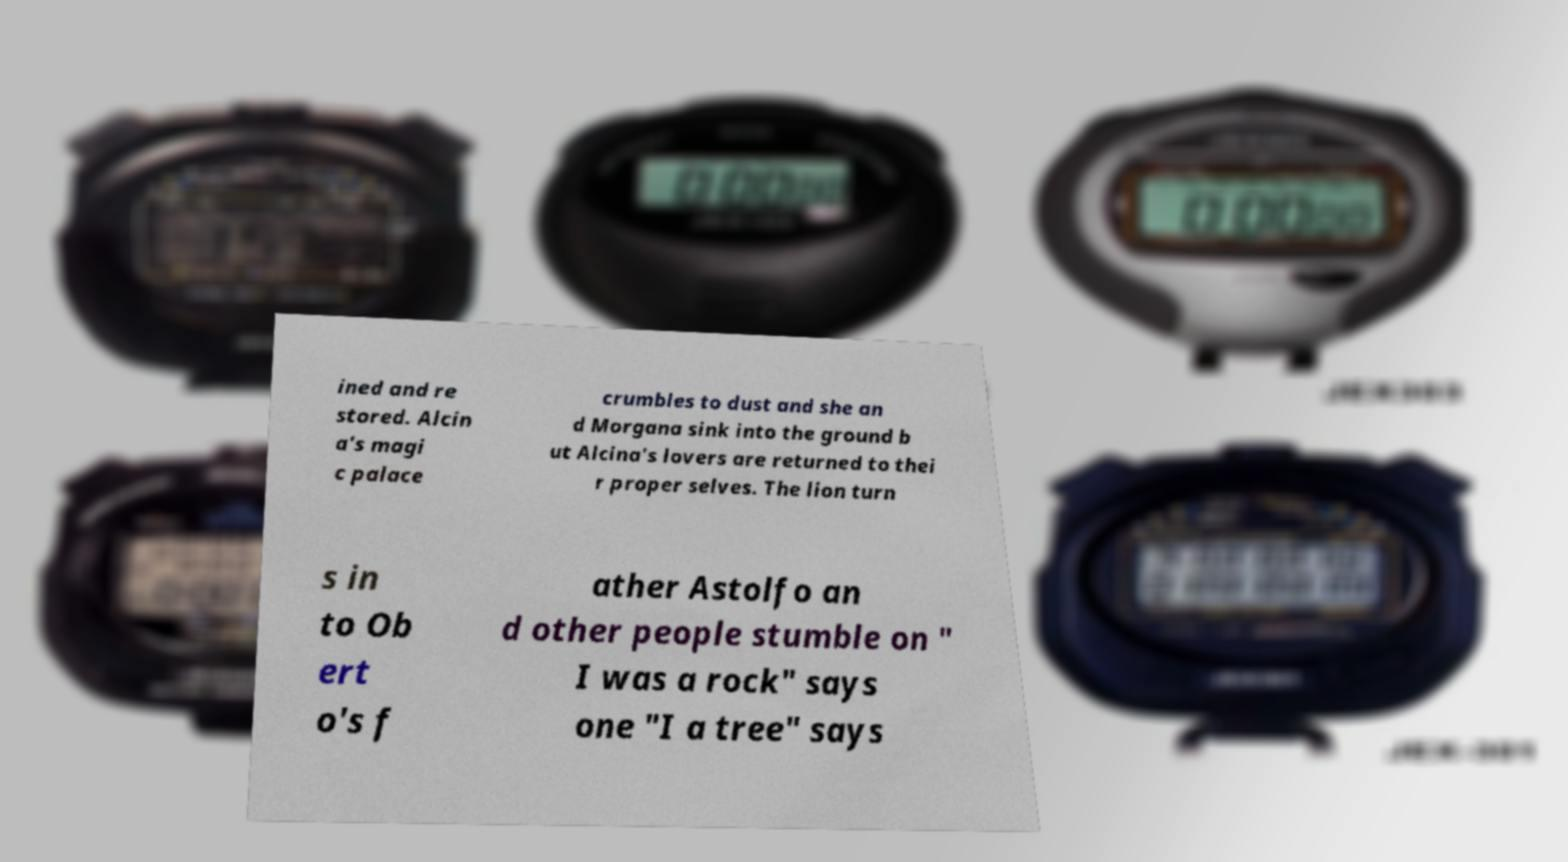I need the written content from this picture converted into text. Can you do that? ined and re stored. Alcin a's magi c palace crumbles to dust and she an d Morgana sink into the ground b ut Alcina's lovers are returned to thei r proper selves. The lion turn s in to Ob ert o's f ather Astolfo an d other people stumble on " I was a rock" says one "I a tree" says 